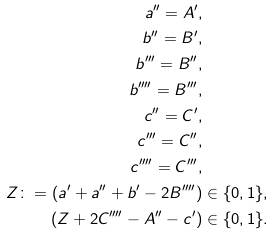Convert formula to latex. <formula><loc_0><loc_0><loc_500><loc_500>a ^ { \prime \prime } = A ^ { \prime } , & \\ b ^ { \prime \prime } = B ^ { \prime } , & \\ b ^ { \prime \prime \prime } = B ^ { \prime \prime } , & \\ b ^ { \prime \prime \prime \prime } = B ^ { \prime \prime \prime } , & \\ c ^ { \prime \prime } = C ^ { \prime } , & \\ c ^ { \prime \prime \prime } = C ^ { \prime \prime } , & \\ c ^ { \prime \prime \prime \prime } = C ^ { \prime \prime \prime } , & \\ Z \colon = ( a ^ { \prime } + a ^ { \prime \prime } + b ^ { \prime } - 2 B ^ { \prime \prime \prime \prime } ) & \in \{ 0 , 1 \} , \\ ( Z + 2 C ^ { \prime \prime \prime \prime } - A ^ { \prime \prime } - c ^ { \prime } ) & \in \{ 0 , 1 \} .</formula> 